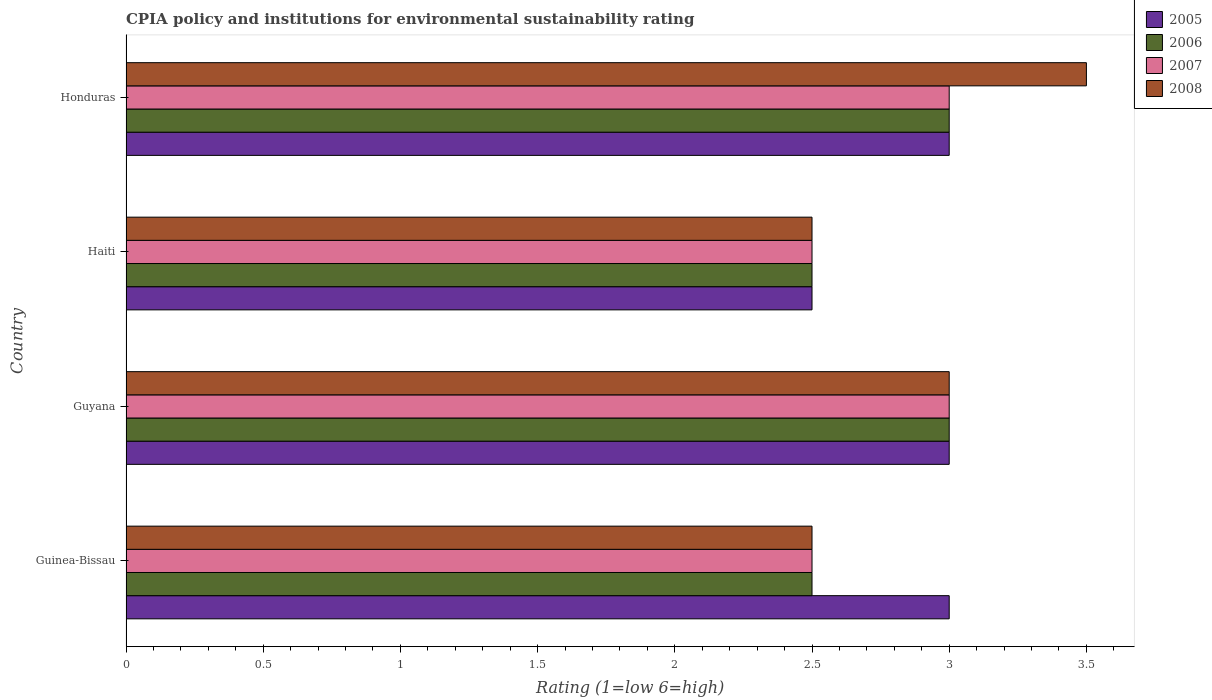Are the number of bars on each tick of the Y-axis equal?
Make the answer very short. Yes. How many bars are there on the 2nd tick from the top?
Ensure brevity in your answer.  4. How many bars are there on the 1st tick from the bottom?
Provide a short and direct response. 4. What is the label of the 4th group of bars from the top?
Make the answer very short. Guinea-Bissau. In which country was the CPIA rating in 2006 maximum?
Your answer should be compact. Guyana. In which country was the CPIA rating in 2008 minimum?
Offer a terse response. Guinea-Bissau. What is the total CPIA rating in 2005 in the graph?
Your response must be concise. 11.5. What is the difference between the CPIA rating in 2006 in Guinea-Bissau and that in Honduras?
Provide a short and direct response. -0.5. What is the average CPIA rating in 2005 per country?
Offer a terse response. 2.88. What is the ratio of the CPIA rating in 2006 in Haiti to that in Honduras?
Your answer should be very brief. 0.83. Is the CPIA rating in 2007 in Guinea-Bissau less than that in Haiti?
Provide a succinct answer. No. What is the difference between the highest and the lowest CPIA rating in 2007?
Your response must be concise. 0.5. What does the 1st bar from the top in Haiti represents?
Provide a short and direct response. 2008. What does the 1st bar from the bottom in Haiti represents?
Offer a terse response. 2005. Is it the case that in every country, the sum of the CPIA rating in 2006 and CPIA rating in 2008 is greater than the CPIA rating in 2007?
Your response must be concise. Yes. Are all the bars in the graph horizontal?
Keep it short and to the point. Yes. How many countries are there in the graph?
Provide a succinct answer. 4. What is the difference between two consecutive major ticks on the X-axis?
Your answer should be compact. 0.5. Are the values on the major ticks of X-axis written in scientific E-notation?
Make the answer very short. No. Does the graph contain grids?
Keep it short and to the point. No. How many legend labels are there?
Offer a very short reply. 4. What is the title of the graph?
Offer a terse response. CPIA policy and institutions for environmental sustainability rating. What is the label or title of the X-axis?
Provide a short and direct response. Rating (1=low 6=high). What is the Rating (1=low 6=high) in 2005 in Guyana?
Your answer should be compact. 3. What is the Rating (1=low 6=high) in 2006 in Guyana?
Make the answer very short. 3. What is the Rating (1=low 6=high) in 2008 in Guyana?
Offer a very short reply. 3. What is the Rating (1=low 6=high) of 2005 in Haiti?
Provide a succinct answer. 2.5. What is the Rating (1=low 6=high) of 2006 in Haiti?
Offer a terse response. 2.5. What is the Rating (1=low 6=high) in 2007 in Haiti?
Provide a succinct answer. 2.5. What is the Rating (1=low 6=high) in 2005 in Honduras?
Offer a very short reply. 3. What is the Rating (1=low 6=high) in 2006 in Honduras?
Give a very brief answer. 3. What is the Rating (1=low 6=high) in 2007 in Honduras?
Offer a terse response. 3. What is the Rating (1=low 6=high) in 2008 in Honduras?
Your answer should be compact. 3.5. Across all countries, what is the maximum Rating (1=low 6=high) of 2007?
Give a very brief answer. 3. Across all countries, what is the maximum Rating (1=low 6=high) of 2008?
Your answer should be very brief. 3.5. What is the total Rating (1=low 6=high) of 2005 in the graph?
Offer a terse response. 11.5. What is the total Rating (1=low 6=high) in 2006 in the graph?
Your answer should be very brief. 11. What is the total Rating (1=low 6=high) in 2007 in the graph?
Provide a short and direct response. 11. What is the difference between the Rating (1=low 6=high) of 2005 in Guinea-Bissau and that in Guyana?
Offer a very short reply. 0. What is the difference between the Rating (1=low 6=high) in 2006 in Guinea-Bissau and that in Guyana?
Your answer should be compact. -0.5. What is the difference between the Rating (1=low 6=high) in 2007 in Guinea-Bissau and that in Guyana?
Keep it short and to the point. -0.5. What is the difference between the Rating (1=low 6=high) in 2007 in Guinea-Bissau and that in Haiti?
Give a very brief answer. 0. What is the difference between the Rating (1=low 6=high) of 2006 in Guinea-Bissau and that in Honduras?
Make the answer very short. -0.5. What is the difference between the Rating (1=low 6=high) of 2008 in Guinea-Bissau and that in Honduras?
Make the answer very short. -1. What is the difference between the Rating (1=low 6=high) in 2005 in Guyana and that in Haiti?
Provide a succinct answer. 0.5. What is the difference between the Rating (1=low 6=high) of 2006 in Guyana and that in Haiti?
Your response must be concise. 0.5. What is the difference between the Rating (1=low 6=high) in 2007 in Guyana and that in Haiti?
Ensure brevity in your answer.  0.5. What is the difference between the Rating (1=low 6=high) in 2006 in Guyana and that in Honduras?
Offer a very short reply. 0. What is the difference between the Rating (1=low 6=high) of 2007 in Guyana and that in Honduras?
Ensure brevity in your answer.  0. What is the difference between the Rating (1=low 6=high) of 2005 in Haiti and that in Honduras?
Make the answer very short. -0.5. What is the difference between the Rating (1=low 6=high) of 2006 in Haiti and that in Honduras?
Ensure brevity in your answer.  -0.5. What is the difference between the Rating (1=low 6=high) of 2008 in Haiti and that in Honduras?
Your response must be concise. -1. What is the difference between the Rating (1=low 6=high) of 2005 in Guinea-Bissau and the Rating (1=low 6=high) of 2006 in Guyana?
Ensure brevity in your answer.  0. What is the difference between the Rating (1=low 6=high) in 2005 in Guinea-Bissau and the Rating (1=low 6=high) in 2008 in Guyana?
Provide a short and direct response. 0. What is the difference between the Rating (1=low 6=high) in 2006 in Guinea-Bissau and the Rating (1=low 6=high) in 2007 in Guyana?
Ensure brevity in your answer.  -0.5. What is the difference between the Rating (1=low 6=high) of 2006 in Guinea-Bissau and the Rating (1=low 6=high) of 2008 in Guyana?
Give a very brief answer. -0.5. What is the difference between the Rating (1=low 6=high) in 2007 in Guinea-Bissau and the Rating (1=low 6=high) in 2008 in Guyana?
Make the answer very short. -0.5. What is the difference between the Rating (1=low 6=high) of 2005 in Guinea-Bissau and the Rating (1=low 6=high) of 2006 in Haiti?
Your answer should be very brief. 0.5. What is the difference between the Rating (1=low 6=high) in 2006 in Guinea-Bissau and the Rating (1=low 6=high) in 2007 in Haiti?
Keep it short and to the point. 0. What is the difference between the Rating (1=low 6=high) in 2006 in Guinea-Bissau and the Rating (1=low 6=high) in 2008 in Haiti?
Ensure brevity in your answer.  0. What is the difference between the Rating (1=low 6=high) of 2005 in Guinea-Bissau and the Rating (1=low 6=high) of 2006 in Honduras?
Your answer should be very brief. 0. What is the difference between the Rating (1=low 6=high) of 2005 in Guinea-Bissau and the Rating (1=low 6=high) of 2007 in Honduras?
Offer a terse response. 0. What is the difference between the Rating (1=low 6=high) in 2005 in Guinea-Bissau and the Rating (1=low 6=high) in 2008 in Honduras?
Offer a very short reply. -0.5. What is the difference between the Rating (1=low 6=high) of 2006 in Guinea-Bissau and the Rating (1=low 6=high) of 2007 in Honduras?
Your answer should be compact. -0.5. What is the difference between the Rating (1=low 6=high) of 2006 in Guinea-Bissau and the Rating (1=low 6=high) of 2008 in Honduras?
Your response must be concise. -1. What is the difference between the Rating (1=low 6=high) in 2005 in Guyana and the Rating (1=low 6=high) in 2006 in Haiti?
Your answer should be very brief. 0.5. What is the difference between the Rating (1=low 6=high) of 2005 in Guyana and the Rating (1=low 6=high) of 2007 in Haiti?
Provide a short and direct response. 0.5. What is the difference between the Rating (1=low 6=high) in 2005 in Guyana and the Rating (1=low 6=high) in 2008 in Haiti?
Keep it short and to the point. 0.5. What is the difference between the Rating (1=low 6=high) in 2007 in Guyana and the Rating (1=low 6=high) in 2008 in Haiti?
Your response must be concise. 0.5. What is the difference between the Rating (1=low 6=high) of 2005 in Guyana and the Rating (1=low 6=high) of 2006 in Honduras?
Your answer should be compact. 0. What is the difference between the Rating (1=low 6=high) of 2006 in Guyana and the Rating (1=low 6=high) of 2007 in Honduras?
Keep it short and to the point. 0. What is the difference between the Rating (1=low 6=high) of 2006 in Guyana and the Rating (1=low 6=high) of 2008 in Honduras?
Give a very brief answer. -0.5. What is the difference between the Rating (1=low 6=high) in 2005 in Haiti and the Rating (1=low 6=high) in 2008 in Honduras?
Provide a short and direct response. -1. What is the difference between the Rating (1=low 6=high) of 2006 in Haiti and the Rating (1=low 6=high) of 2007 in Honduras?
Make the answer very short. -0.5. What is the difference between the Rating (1=low 6=high) of 2006 in Haiti and the Rating (1=low 6=high) of 2008 in Honduras?
Provide a short and direct response. -1. What is the average Rating (1=low 6=high) of 2005 per country?
Keep it short and to the point. 2.88. What is the average Rating (1=low 6=high) in 2006 per country?
Keep it short and to the point. 2.75. What is the average Rating (1=low 6=high) of 2007 per country?
Keep it short and to the point. 2.75. What is the average Rating (1=low 6=high) of 2008 per country?
Make the answer very short. 2.88. What is the difference between the Rating (1=low 6=high) in 2005 and Rating (1=low 6=high) in 2007 in Guinea-Bissau?
Your response must be concise. 0.5. What is the difference between the Rating (1=low 6=high) in 2005 and Rating (1=low 6=high) in 2008 in Guinea-Bissau?
Your response must be concise. 0.5. What is the difference between the Rating (1=low 6=high) of 2006 and Rating (1=low 6=high) of 2007 in Guinea-Bissau?
Offer a very short reply. 0. What is the difference between the Rating (1=low 6=high) of 2006 and Rating (1=low 6=high) of 2008 in Guinea-Bissau?
Keep it short and to the point. 0. What is the difference between the Rating (1=low 6=high) of 2005 and Rating (1=low 6=high) of 2007 in Guyana?
Provide a succinct answer. 0. What is the difference between the Rating (1=low 6=high) in 2005 and Rating (1=low 6=high) in 2008 in Haiti?
Offer a terse response. 0. What is the difference between the Rating (1=low 6=high) of 2006 and Rating (1=low 6=high) of 2008 in Haiti?
Your answer should be compact. 0. What is the difference between the Rating (1=low 6=high) of 2007 and Rating (1=low 6=high) of 2008 in Haiti?
Offer a very short reply. 0. What is the difference between the Rating (1=low 6=high) of 2005 and Rating (1=low 6=high) of 2007 in Honduras?
Ensure brevity in your answer.  0. What is the difference between the Rating (1=low 6=high) of 2005 and Rating (1=low 6=high) of 2008 in Honduras?
Your answer should be very brief. -0.5. What is the difference between the Rating (1=low 6=high) of 2007 and Rating (1=low 6=high) of 2008 in Honduras?
Offer a very short reply. -0.5. What is the ratio of the Rating (1=low 6=high) in 2006 in Guinea-Bissau to that in Guyana?
Give a very brief answer. 0.83. What is the ratio of the Rating (1=low 6=high) in 2007 in Guinea-Bissau to that in Guyana?
Provide a short and direct response. 0.83. What is the ratio of the Rating (1=low 6=high) of 2008 in Guinea-Bissau to that in Guyana?
Keep it short and to the point. 0.83. What is the ratio of the Rating (1=low 6=high) in 2005 in Guinea-Bissau to that in Haiti?
Provide a short and direct response. 1.2. What is the ratio of the Rating (1=low 6=high) of 2006 in Guinea-Bissau to that in Haiti?
Make the answer very short. 1. What is the ratio of the Rating (1=low 6=high) in 2007 in Guinea-Bissau to that in Haiti?
Provide a short and direct response. 1. What is the ratio of the Rating (1=low 6=high) in 2008 in Guinea-Bissau to that in Haiti?
Offer a terse response. 1. What is the ratio of the Rating (1=low 6=high) of 2005 in Guinea-Bissau to that in Honduras?
Your response must be concise. 1. What is the ratio of the Rating (1=low 6=high) of 2006 in Guinea-Bissau to that in Honduras?
Make the answer very short. 0.83. What is the ratio of the Rating (1=low 6=high) of 2008 in Guinea-Bissau to that in Honduras?
Provide a short and direct response. 0.71. What is the ratio of the Rating (1=low 6=high) in 2005 in Guyana to that in Haiti?
Your answer should be very brief. 1.2. What is the ratio of the Rating (1=low 6=high) in 2006 in Guyana to that in Haiti?
Your answer should be very brief. 1.2. What is the ratio of the Rating (1=low 6=high) of 2008 in Guyana to that in Honduras?
Offer a terse response. 0.86. What is the ratio of the Rating (1=low 6=high) in 2006 in Haiti to that in Honduras?
Provide a short and direct response. 0.83. What is the ratio of the Rating (1=low 6=high) of 2007 in Haiti to that in Honduras?
Offer a very short reply. 0.83. What is the ratio of the Rating (1=low 6=high) in 2008 in Haiti to that in Honduras?
Make the answer very short. 0.71. What is the difference between the highest and the second highest Rating (1=low 6=high) in 2007?
Your answer should be compact. 0. What is the difference between the highest and the second highest Rating (1=low 6=high) in 2008?
Your answer should be very brief. 0.5. What is the difference between the highest and the lowest Rating (1=low 6=high) in 2005?
Offer a terse response. 0.5. What is the difference between the highest and the lowest Rating (1=low 6=high) of 2006?
Offer a very short reply. 0.5. What is the difference between the highest and the lowest Rating (1=low 6=high) in 2007?
Provide a short and direct response. 0.5. What is the difference between the highest and the lowest Rating (1=low 6=high) of 2008?
Your answer should be very brief. 1. 